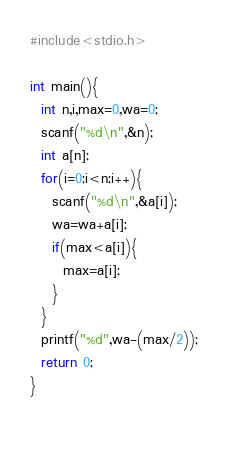<code> <loc_0><loc_0><loc_500><loc_500><_C_>#include<stdio.h>

int main(){
  int n,i,max=0,wa=0;
  scanf("%d\n",&n);
  int a[n];
  for(i=0;i<n;i++){
    scanf("%d\n",&a[i]);
    wa=wa+a[i];
    if(max<a[i]){
      max=a[i];
    }
  }
  printf("%d",wa-(max/2));
  return 0;
}
  </code> 